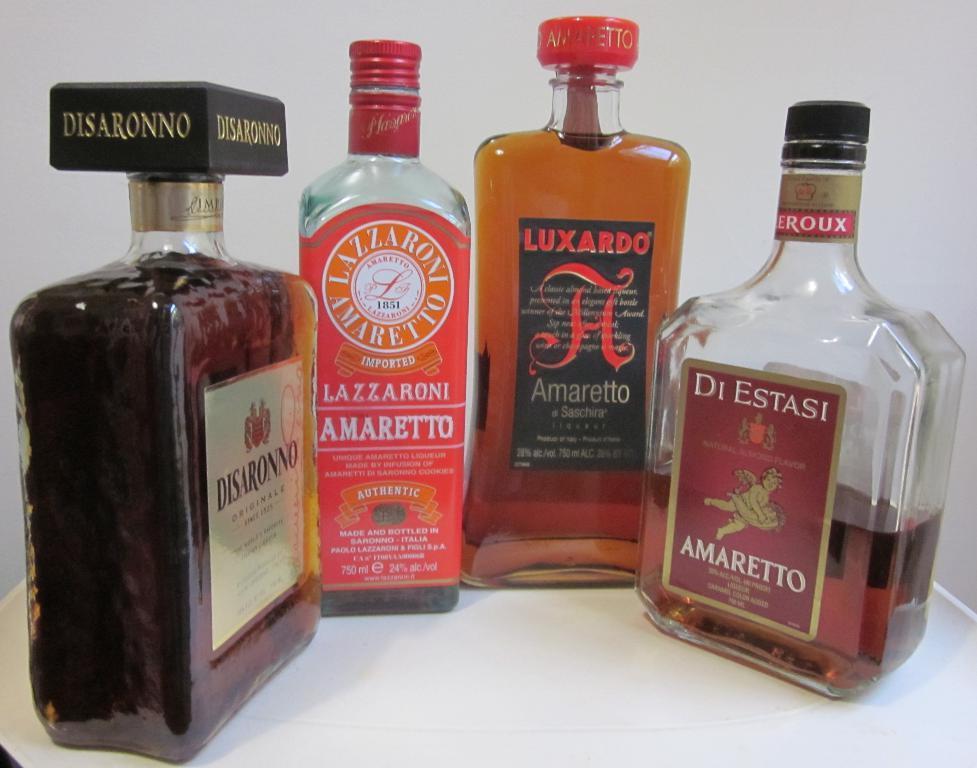Can you describe this image briefly? Bottom of the image there is a table, On the table four bottles are there. 